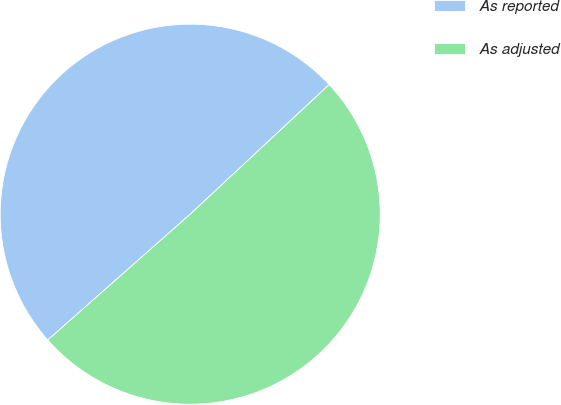Convert chart to OTSL. <chart><loc_0><loc_0><loc_500><loc_500><pie_chart><fcel>As reported<fcel>As adjusted<nl><fcel>49.57%<fcel>50.43%<nl></chart> 